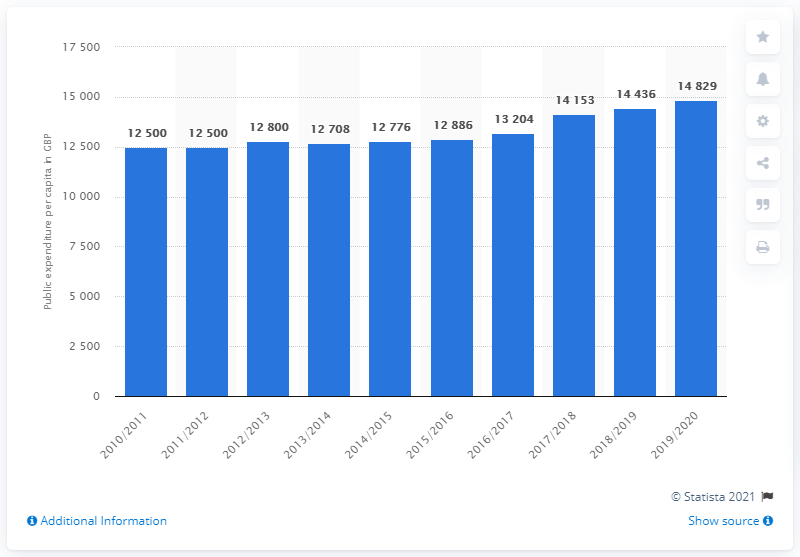Indicate a few pertinent items in this graphic. In 2019/20, the government in Scotland spent approximately 14,829 per capita, according to available data. 